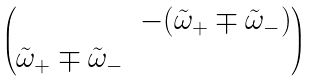Convert formula to latex. <formula><loc_0><loc_0><loc_500><loc_500>\begin{pmatrix} & - ( \tilde { \omega } _ { + } \mp \tilde { \omega } _ { - } ) \\ \tilde { \omega } _ { + } \mp \tilde { \omega } _ { - } & \end{pmatrix}</formula> 